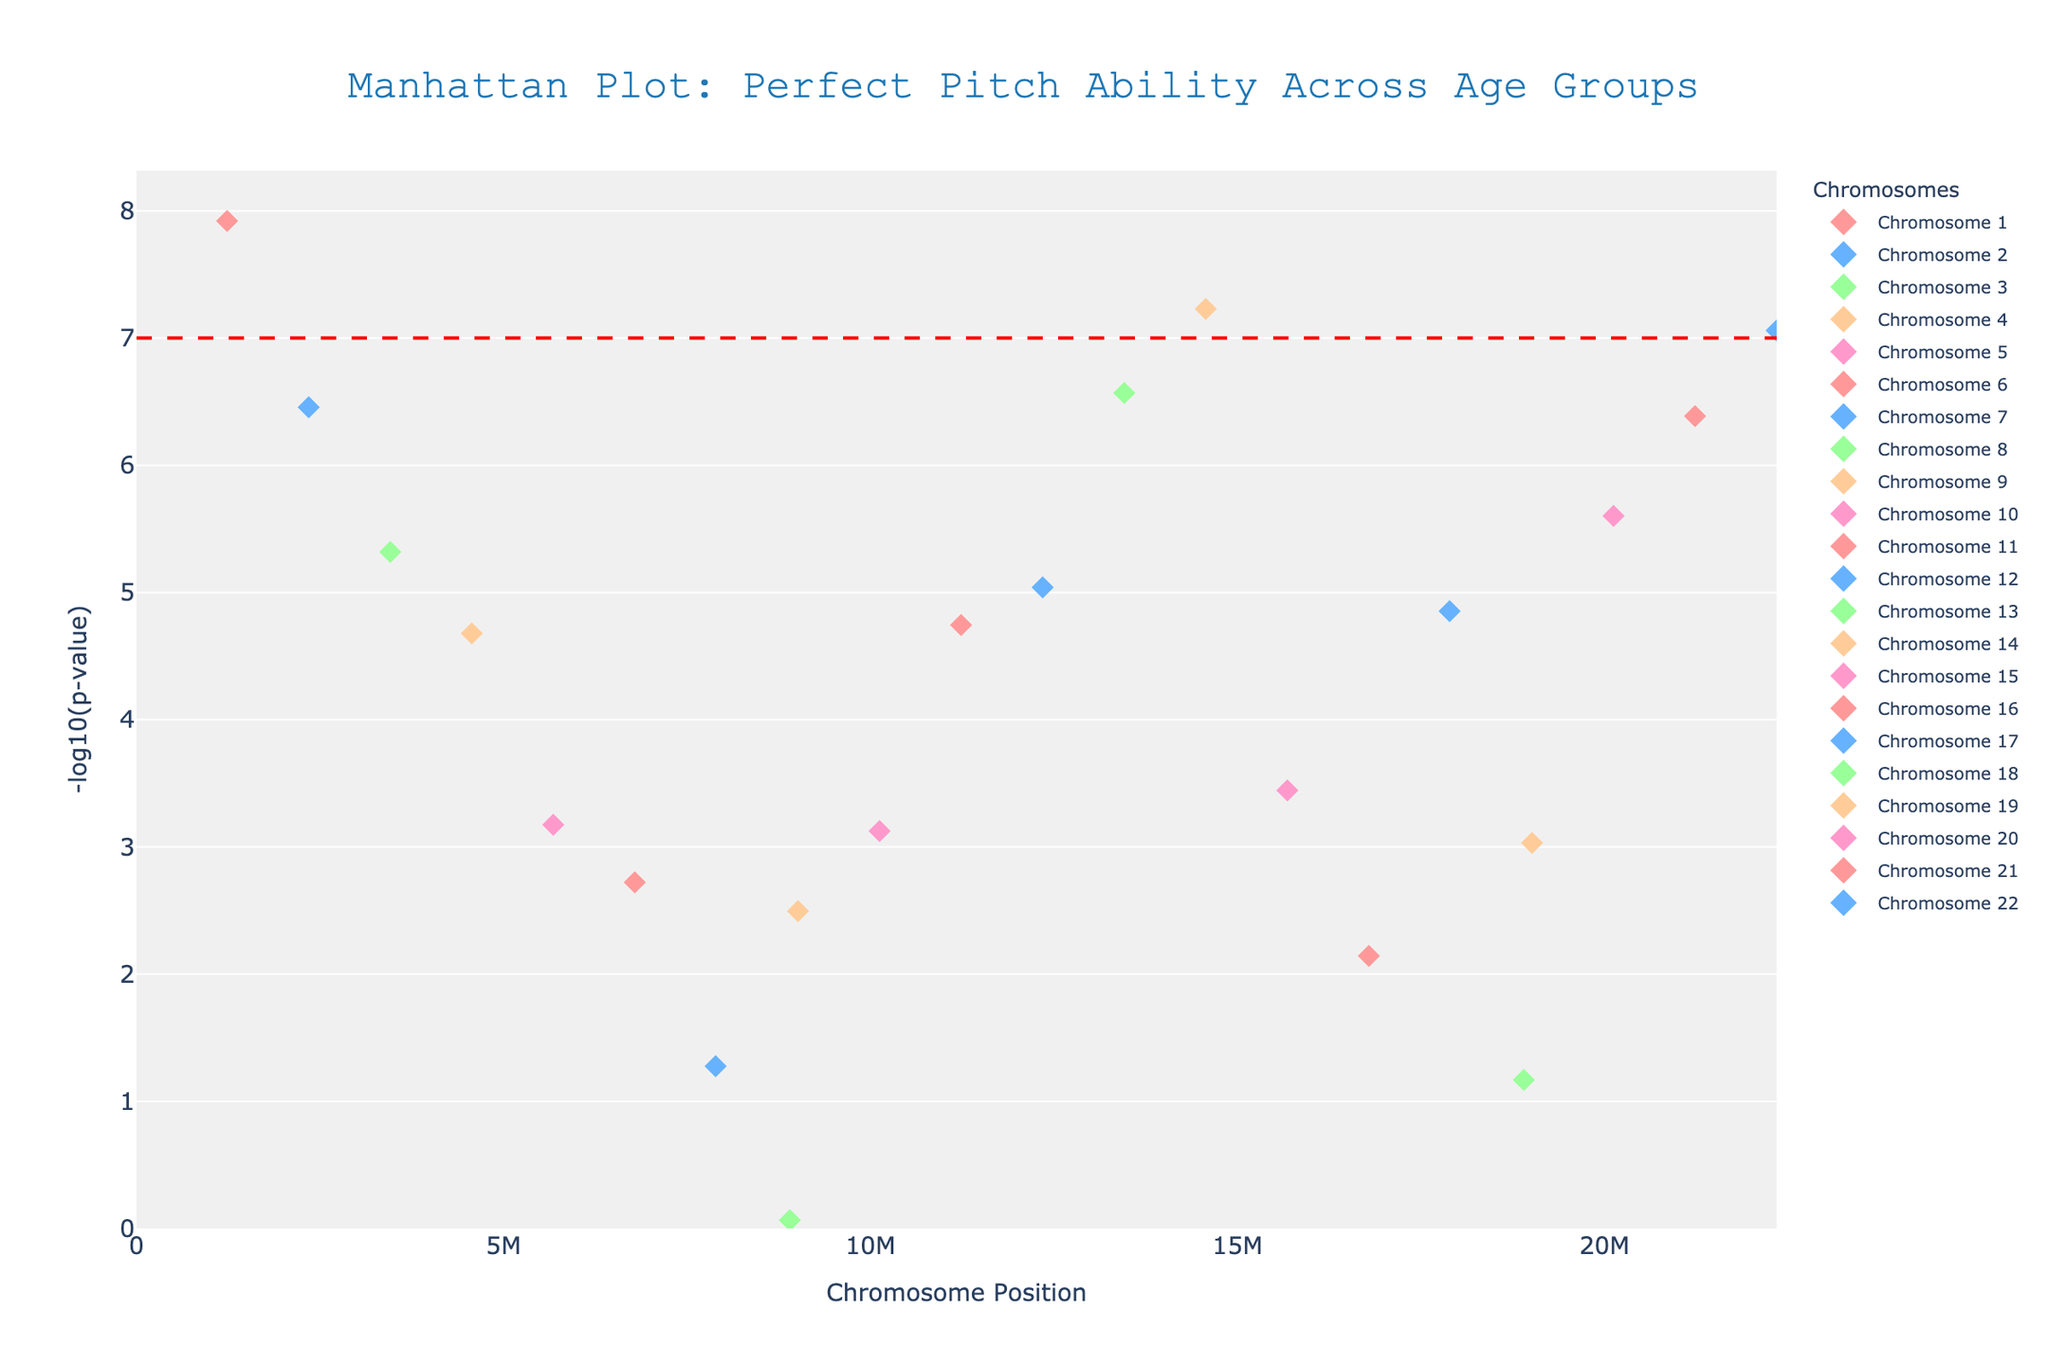What is the title of the figure? The title of the figure is displayed prominently at the top of the plot.
Answer: Manhattan Plot: Perfect Pitch Ability Across Age Groups Which chromosome has the SNP with the lowest p-value? The Manhattan plot shows the p-values by their -log10 values. The SNP with the lowest p-value will have the highest -log10(p-value). Looking for the tallest marker, we find it on chromosome 1.
Answer: Chromosome 1 How many chromosomes show SNPs with p-values below the genome-wide significance threshold? The significance threshold is indicated by the red dashed line at y = 7. Count the number of chromosomes that have markers above this line.
Answer: 5 Which gene on chromosome 4 has been identified in the study? Locate chromosome 4 and find the gene associated with the marker. The hover text lists the gene as COMT.
Answer: COMT Which chromosome contains the gene DTNBP1? Locate the gene DTNBP1 in the hover text and identify the chromosome it belongs to by following the marker.
Answer: Chromosome 13 What are the p-values for chromosomes 6 and 7? Refer to the y-axis positions of the markers on chromosomes 6 and 7, and convert the -log10(p-values) back to p-values. For chromosome 6: -log10(0.0019) ≈ 2.72, and for chromosome 7: -log10(0.053) ≈ 1.28.
Answer: Chromosome 6: 0.0019, Chromosome 7: 0.053 Which gene on chromosome 11 has the lowest p-value? Look at chromosome 11 and compare the heights of the markers. The gene BDNF corresponds to the tallest marker.
Answer: BDNF Is there a gene with a p-value below 1e-7 on chromosome 22? Check if any markers on chromosome 22 are above the significance threshold of y = 7. There is one marker on chromosome 22 above this line corresponding to COMT.
Answer: Yes What is the average -log10(p-value) of genes on chromosomes 1, 5, and 10? Calculate the -log10(p-values) for SNPs on chromosomes 1, 5, and 10. (1.2e-8, 6.7e-4, 7.5e-4) -> (-log10(1.2e-8), -log10(6.7e-4), -log10(7.5e-4)) -> (7.92, 3.17, 3.12). Then, average these values: (7.92 + 3.17 + 3.12)/3 ≈ 4.74.
Answer: 4.74 